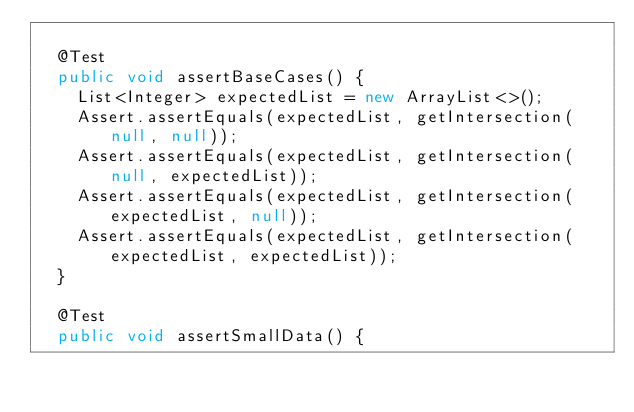Convert code to text. <code><loc_0><loc_0><loc_500><loc_500><_Java_>
  @Test
  public void assertBaseCases() {
    List<Integer> expectedList = new ArrayList<>();
    Assert.assertEquals(expectedList, getIntersection(null, null));
    Assert.assertEquals(expectedList, getIntersection(null, expectedList));
    Assert.assertEquals(expectedList, getIntersection(expectedList, null));
    Assert.assertEquals(expectedList, getIntersection(expectedList, expectedList));
  }

  @Test
  public void assertSmallData() {</code> 